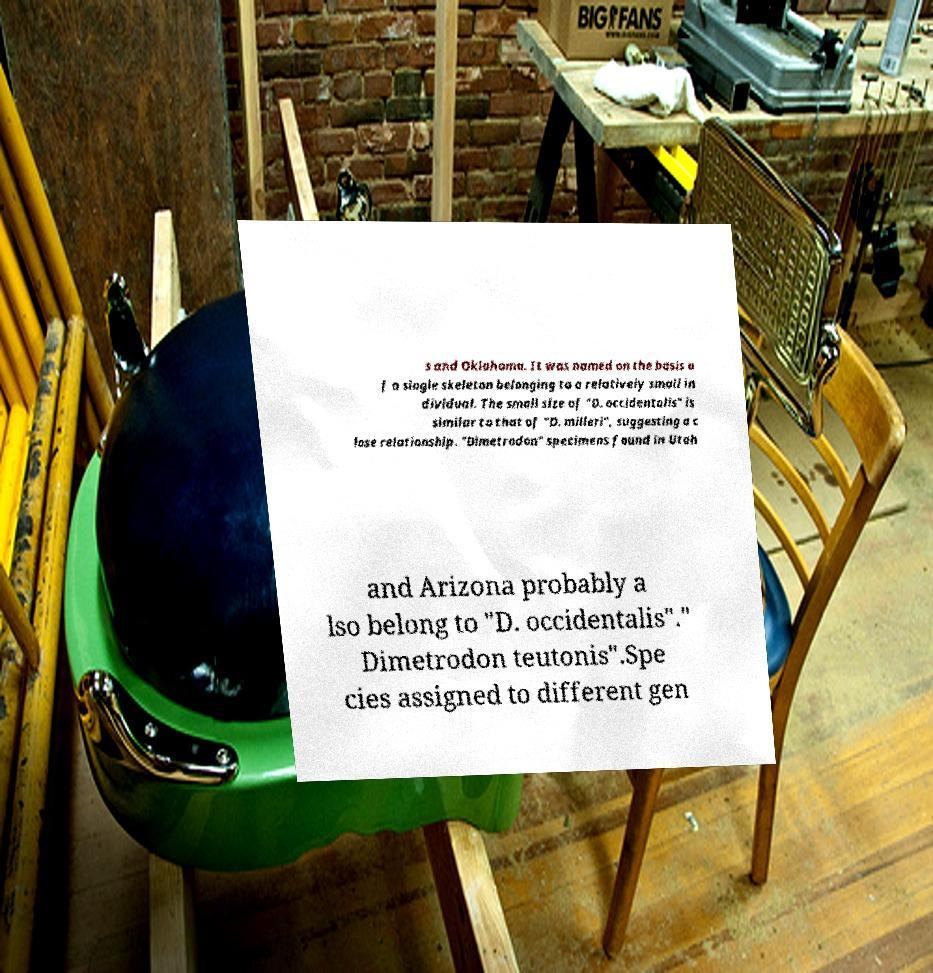Please read and relay the text visible in this image. What does it say? s and Oklahoma. It was named on the basis o f a single skeleton belonging to a relatively small in dividual. The small size of "D. occidentalis" is similar to that of "D. milleri", suggesting a c lose relationship. "Dimetrodon" specimens found in Utah and Arizona probably a lso belong to "D. occidentalis"." Dimetrodon teutonis".Spe cies assigned to different gen 